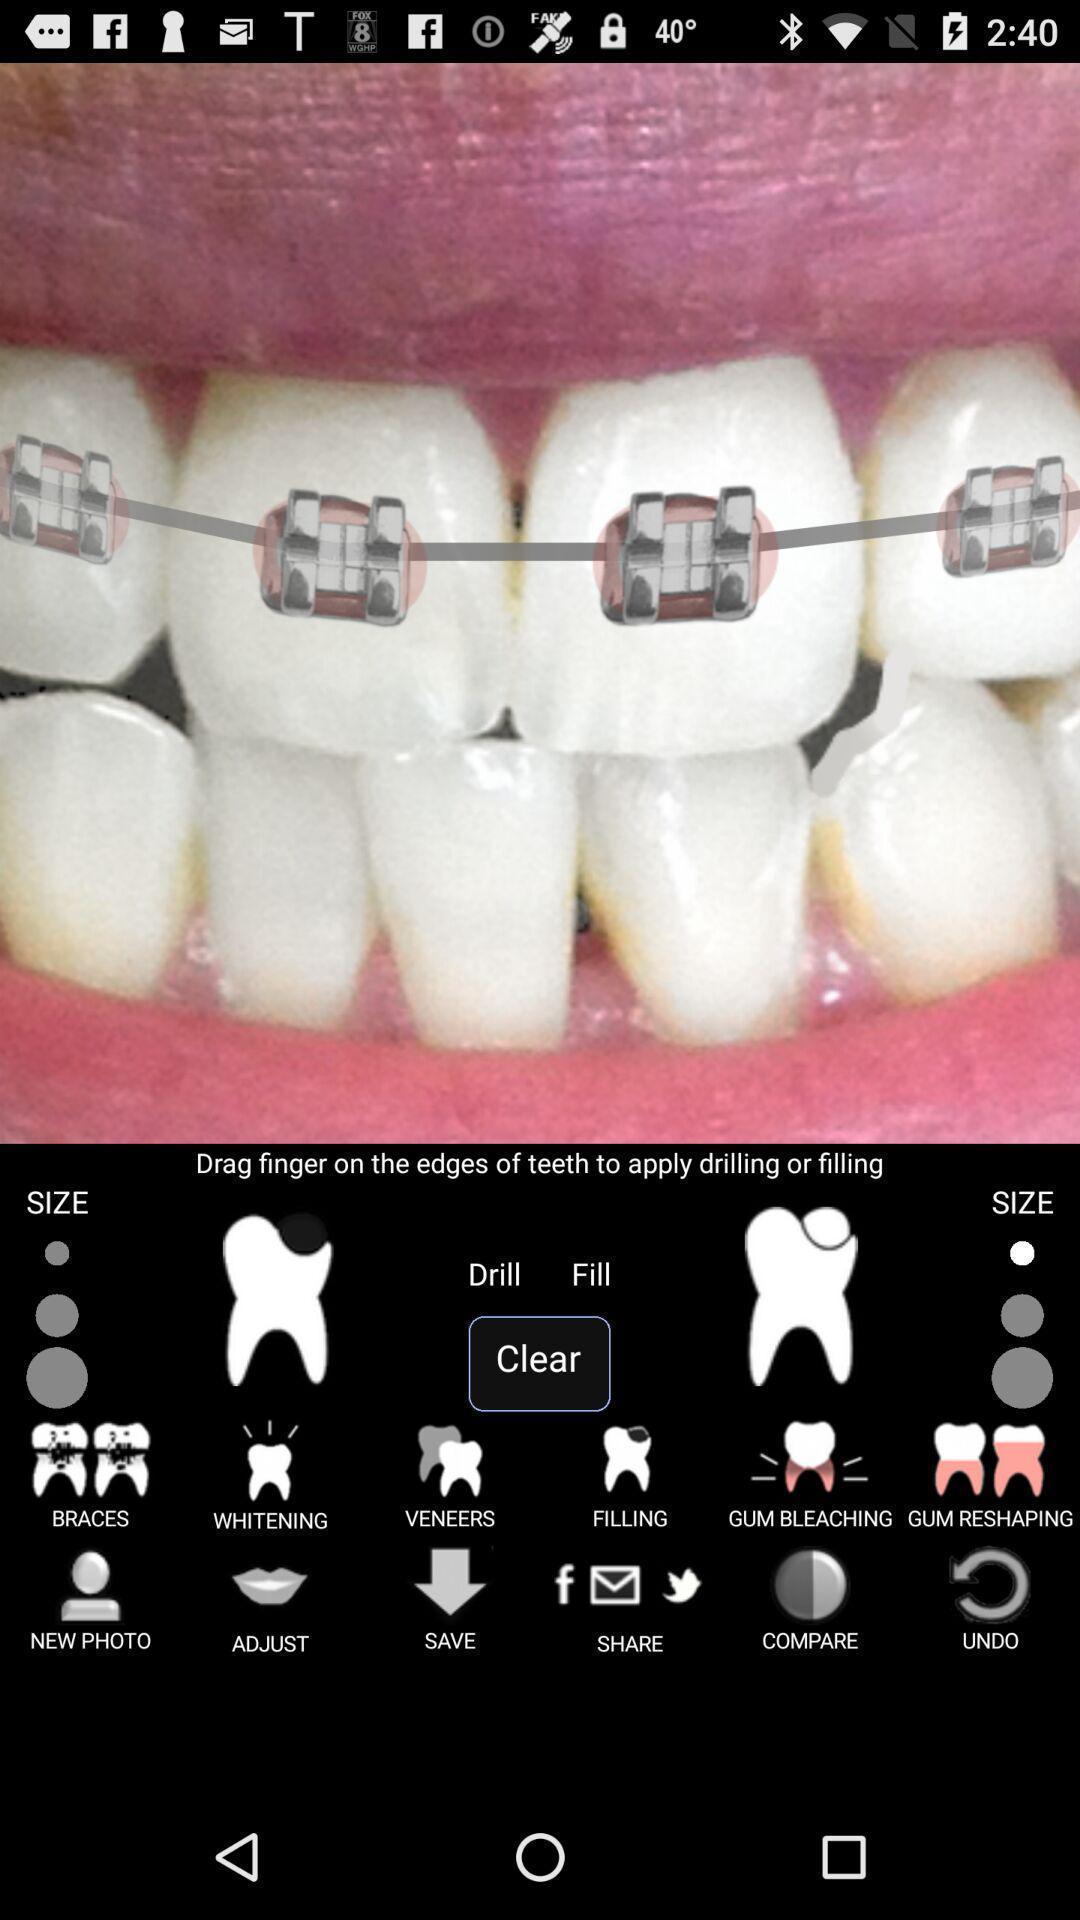Provide a detailed account of this screenshot. Screen shows set of teeth with braces. 